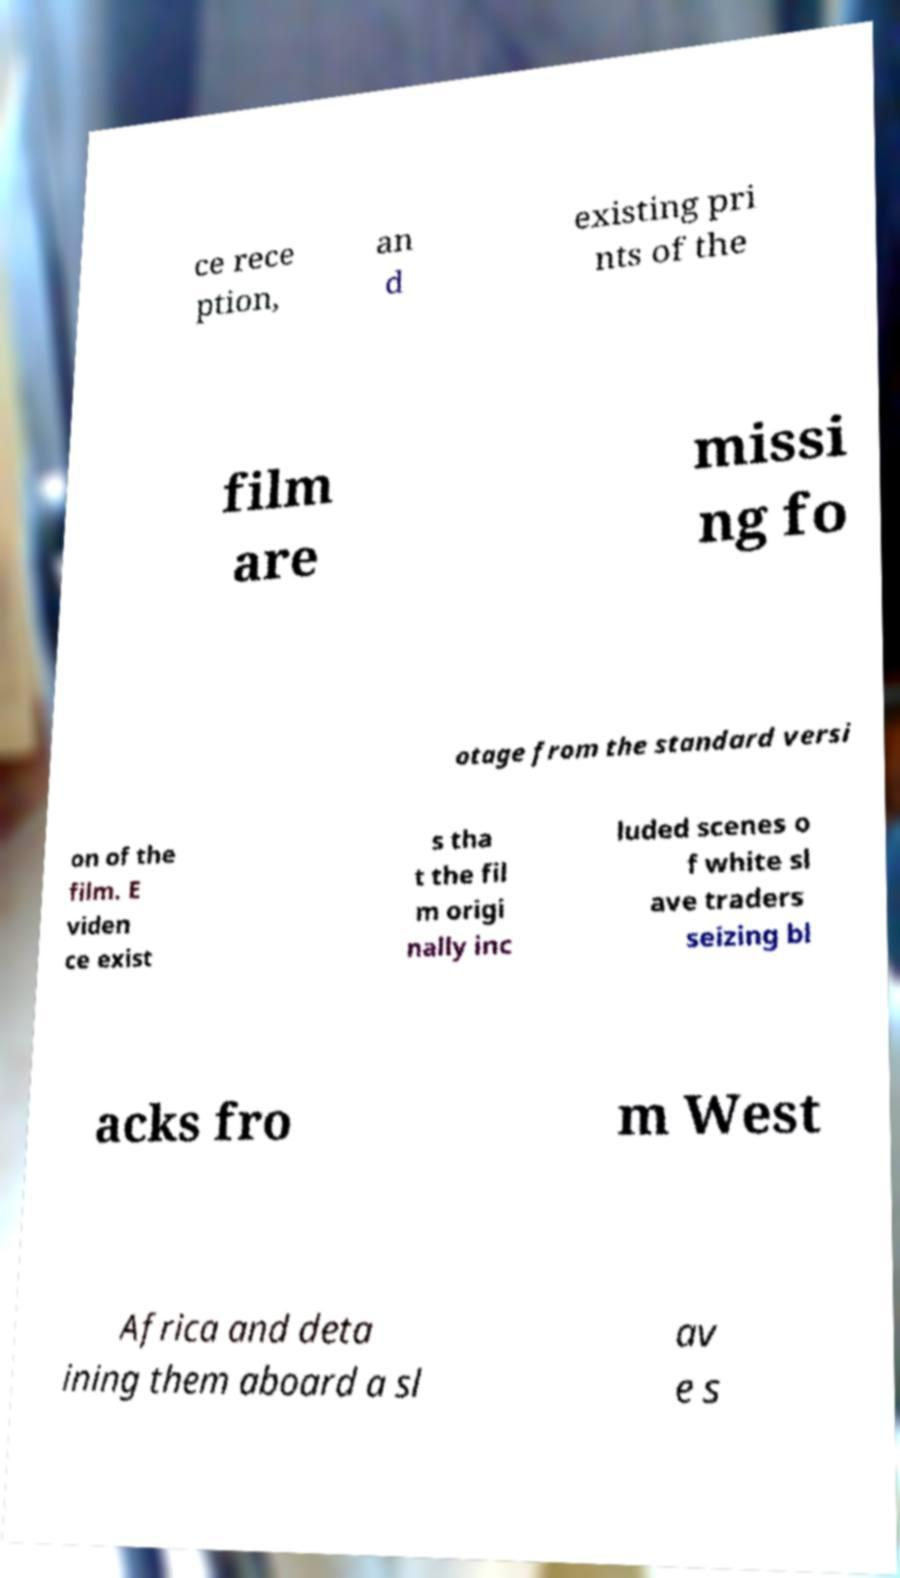I need the written content from this picture converted into text. Can you do that? ce rece ption, an d existing pri nts of the film are missi ng fo otage from the standard versi on of the film. E viden ce exist s tha t the fil m origi nally inc luded scenes o f white sl ave traders seizing bl acks fro m West Africa and deta ining them aboard a sl av e s 